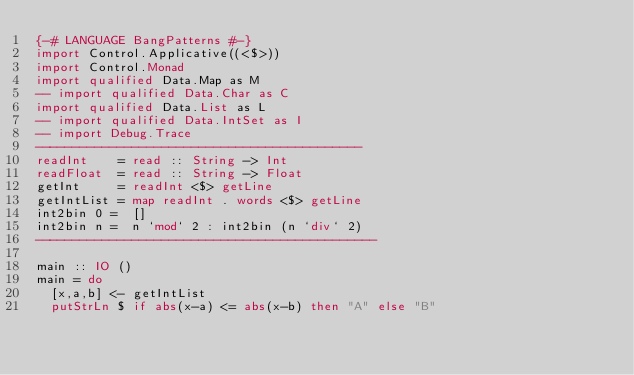<code> <loc_0><loc_0><loc_500><loc_500><_Haskell_>{-# LANGUAGE BangPatterns #-}
import Control.Applicative((<$>))
import Control.Monad
import qualified Data.Map as M
-- import qualified Data.Char as C
import qualified Data.List as L
-- import qualified Data.IntSet as I
-- import Debug.Trace
--------------------------------------------
readInt    = read :: String -> Int
readFloat  = read :: String -> Float
getInt     = readInt <$> getLine
getIntList = map readInt . words <$> getLine
int2bin 0 =  []
int2bin n =  n `mod` 2 : int2bin (n `div` 2)
----------------------------------------------

main :: IO ()
main = do
  [x,a,b] <- getIntList
  putStrLn $ if abs(x-a) <= abs(x-b) then "A" else "B"
</code> 